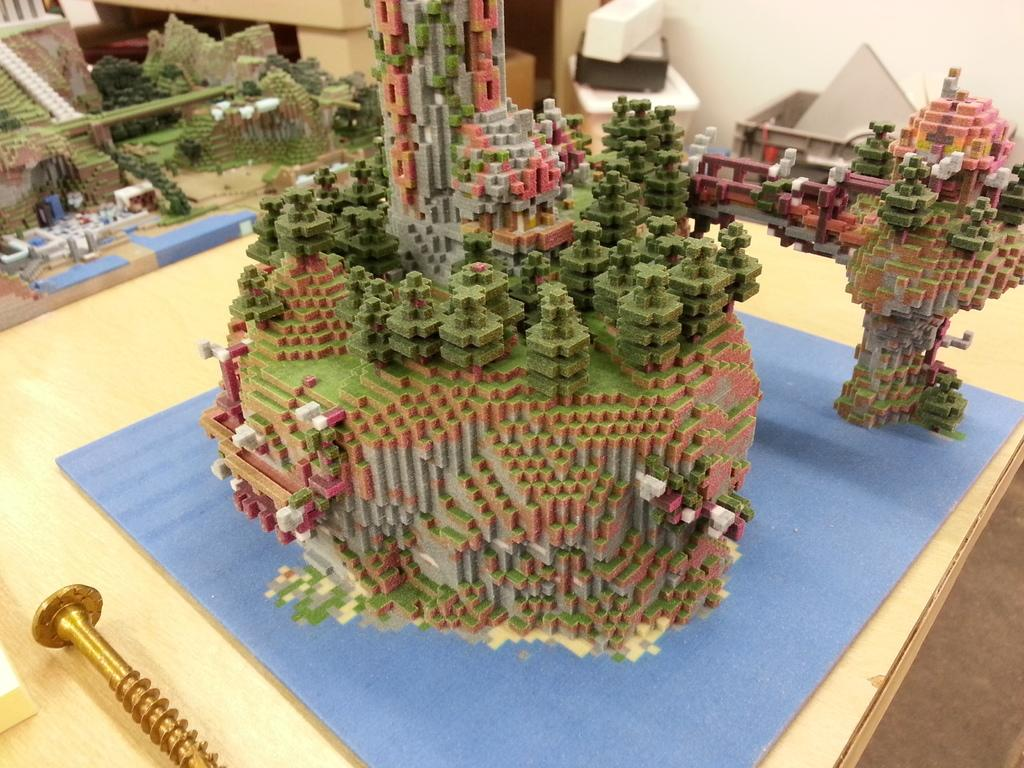What is on the table in the image? There are colorful miniatures on the table. Can you describe the miniatures in more detail? Unfortunately, the facts provided do not give any further details about the miniatures. Is there anything else visible on the table besides the miniatures? The facts provided do not mention any other objects on the table. What is the location of the nail in the image? The nail is visible in the image, located at the left bottom. What type of spoon is being used by the aunt in the image? There is no aunt or spoon present in the image. What is the cord used for in the image? There is no cord present in the image. 